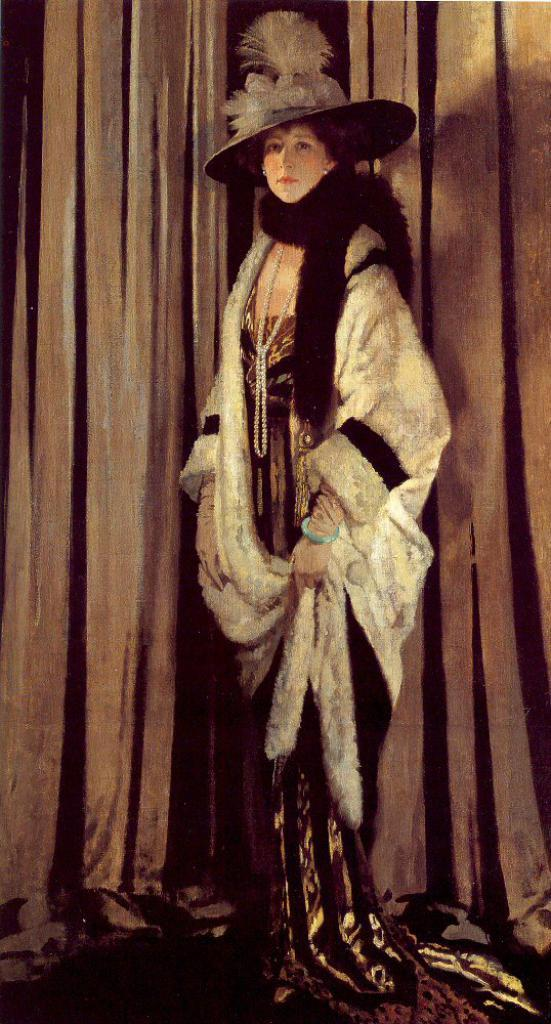Who is the main subject in the image? There is a lady in the center of the image. What is the lady wearing? The lady is wearing a costume. What can be seen in the background of the image? There is a curtain in the background of the image. How many volleyballs are visible in the image? There are no volleyballs present in the image. What type of muscle is the lady flexing in the image? The image does not show the lady flexing any muscles. 